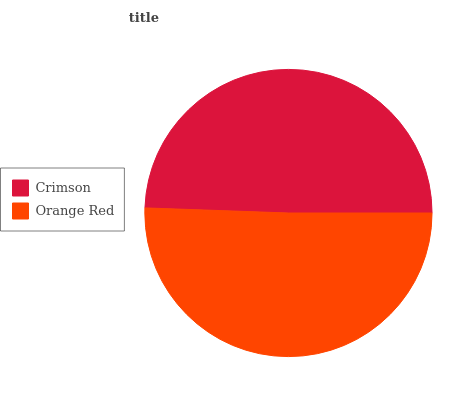Is Crimson the minimum?
Answer yes or no. Yes. Is Orange Red the maximum?
Answer yes or no. Yes. Is Orange Red the minimum?
Answer yes or no. No. Is Orange Red greater than Crimson?
Answer yes or no. Yes. Is Crimson less than Orange Red?
Answer yes or no. Yes. Is Crimson greater than Orange Red?
Answer yes or no. No. Is Orange Red less than Crimson?
Answer yes or no. No. Is Orange Red the high median?
Answer yes or no. Yes. Is Crimson the low median?
Answer yes or no. Yes. Is Crimson the high median?
Answer yes or no. No. Is Orange Red the low median?
Answer yes or no. No. 